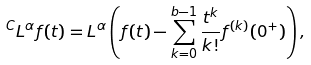<formula> <loc_0><loc_0><loc_500><loc_500>{ } ^ { C } L ^ { \alpha } f ( t ) = L ^ { \alpha } \left ( f ( t ) - \sum _ { k = 0 } ^ { b - 1 } \frac { t ^ { k } } { k ! } f ^ { ( k ) } ( 0 ^ { + } ) \right ) ,</formula> 